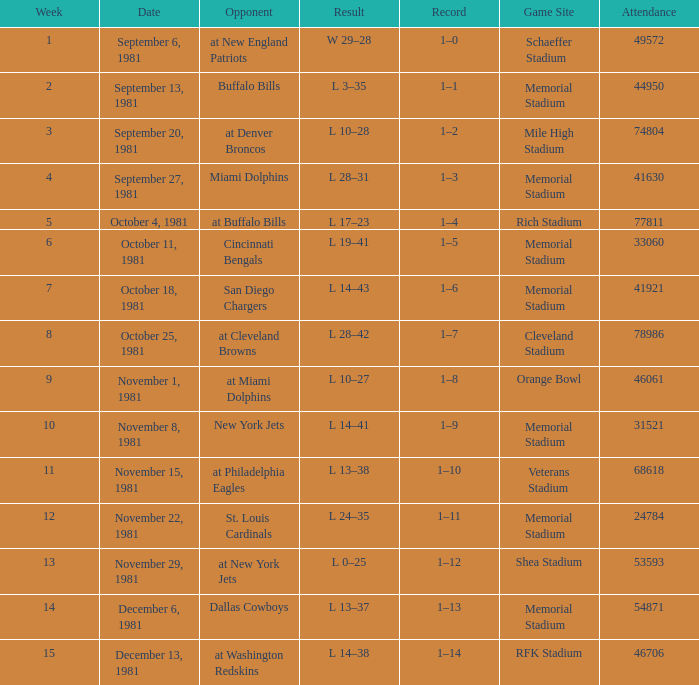When 74804 is the participation, which week is it? 3.0. 